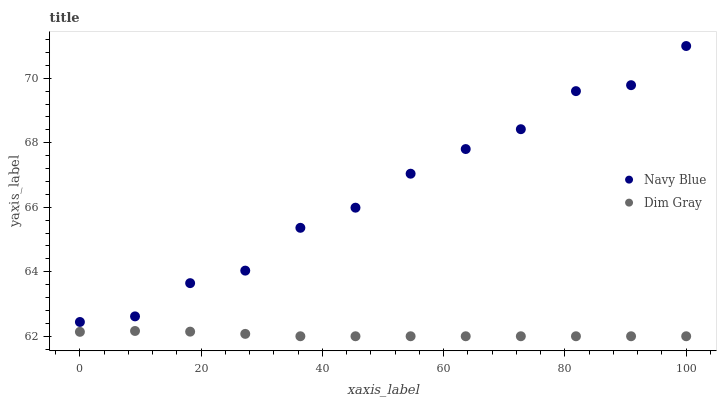Does Dim Gray have the minimum area under the curve?
Answer yes or no. Yes. Does Navy Blue have the maximum area under the curve?
Answer yes or no. Yes. Does Dim Gray have the maximum area under the curve?
Answer yes or no. No. Is Dim Gray the smoothest?
Answer yes or no. Yes. Is Navy Blue the roughest?
Answer yes or no. Yes. Is Dim Gray the roughest?
Answer yes or no. No. Does Dim Gray have the lowest value?
Answer yes or no. Yes. Does Navy Blue have the highest value?
Answer yes or no. Yes. Does Dim Gray have the highest value?
Answer yes or no. No. Is Dim Gray less than Navy Blue?
Answer yes or no. Yes. Is Navy Blue greater than Dim Gray?
Answer yes or no. Yes. Does Dim Gray intersect Navy Blue?
Answer yes or no. No. 